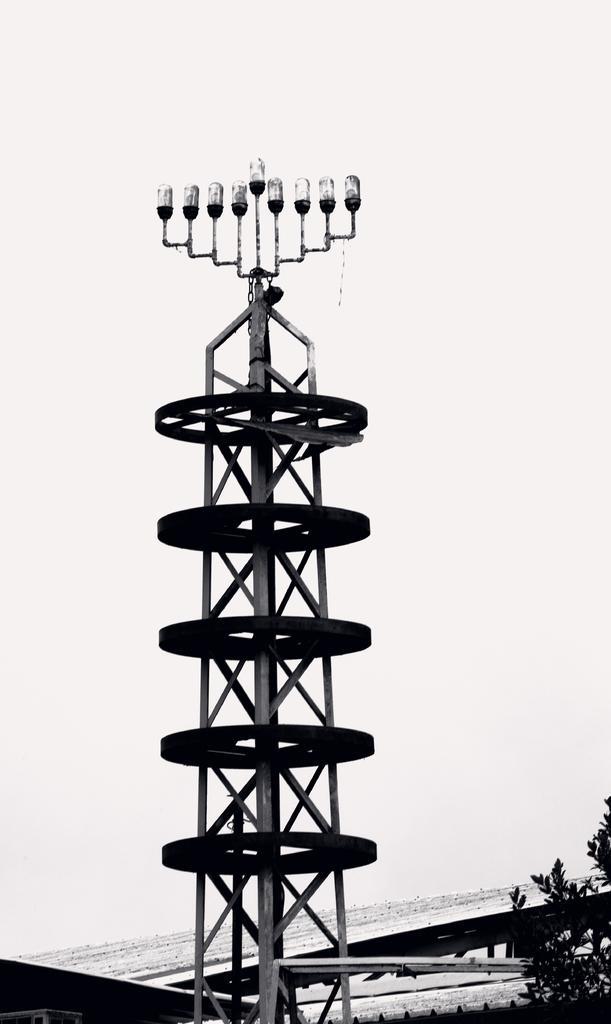Can you describe this image briefly? In the image I can see a tower, roof and a tree. The picture is black and white in color. 